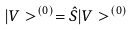<formula> <loc_0><loc_0><loc_500><loc_500>| V > ^ { ( 0 ) } = \hat { S } | V > ^ { ( 0 ) }</formula> 